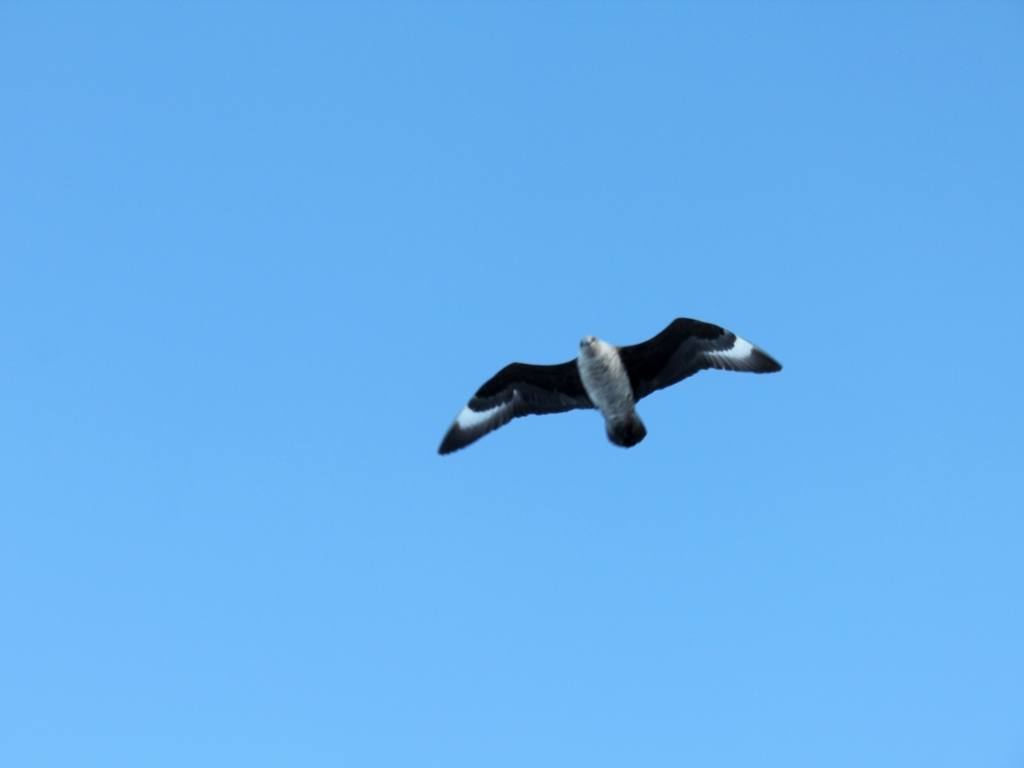Does the image lack clarity? While the image could have been sharper, especially around the edges of the bird, it captures the essence of the moment. The bird is in focus, allowing us to distinguish its main features. Blurriness around the edges can sometimes result from the motion of the bird during the exposure, which conveys a sense of movement and can be an intentional aspect of wildlife photography. 